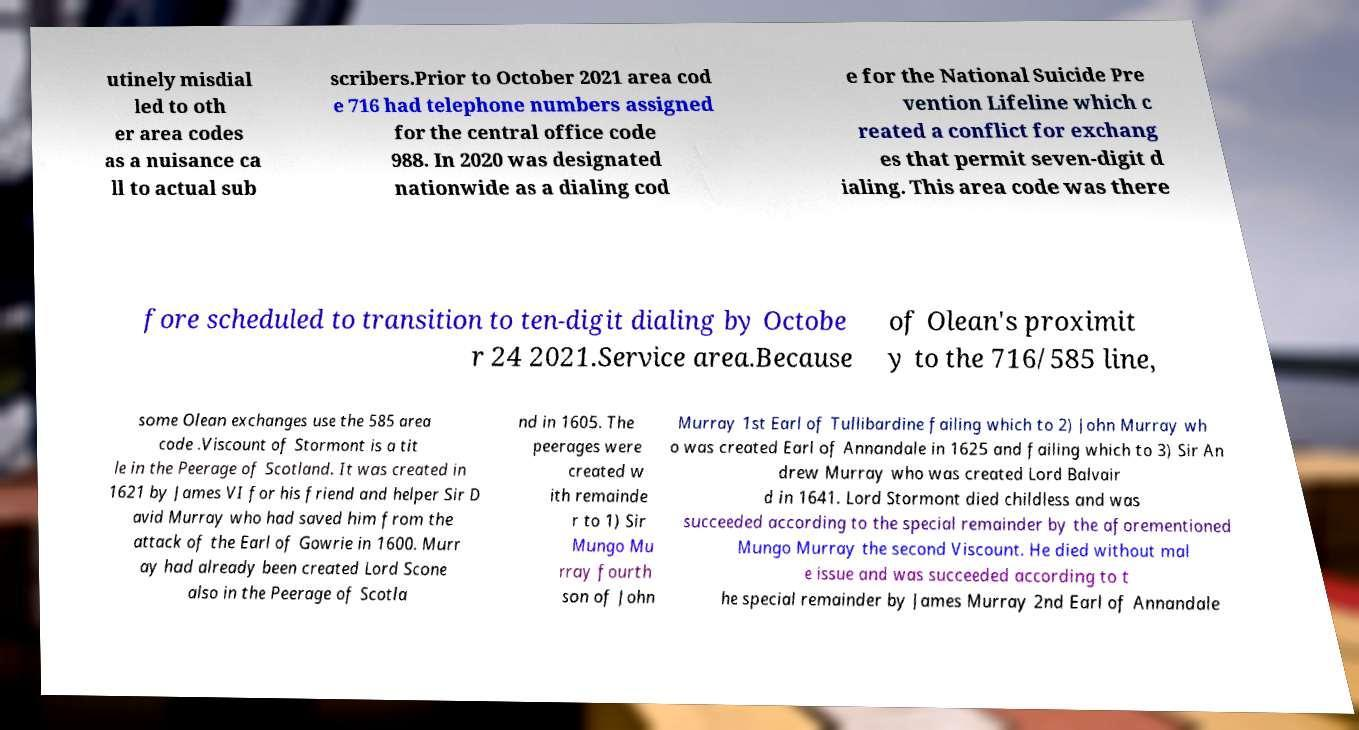Can you accurately transcribe the text from the provided image for me? utinely misdial led to oth er area codes as a nuisance ca ll to actual sub scribers.Prior to October 2021 area cod e 716 had telephone numbers assigned for the central office code 988. In 2020 was designated nationwide as a dialing cod e for the National Suicide Pre vention Lifeline which c reated a conflict for exchang es that permit seven-digit d ialing. This area code was there fore scheduled to transition to ten-digit dialing by Octobe r 24 2021.Service area.Because of Olean's proximit y to the 716/585 line, some Olean exchanges use the 585 area code .Viscount of Stormont is a tit le in the Peerage of Scotland. It was created in 1621 by James VI for his friend and helper Sir D avid Murray who had saved him from the attack of the Earl of Gowrie in 1600. Murr ay had already been created Lord Scone also in the Peerage of Scotla nd in 1605. The peerages were created w ith remainde r to 1) Sir Mungo Mu rray fourth son of John Murray 1st Earl of Tullibardine failing which to 2) John Murray wh o was created Earl of Annandale in 1625 and failing which to 3) Sir An drew Murray who was created Lord Balvair d in 1641. Lord Stormont died childless and was succeeded according to the special remainder by the aforementioned Mungo Murray the second Viscount. He died without mal e issue and was succeeded according to t he special remainder by James Murray 2nd Earl of Annandale 